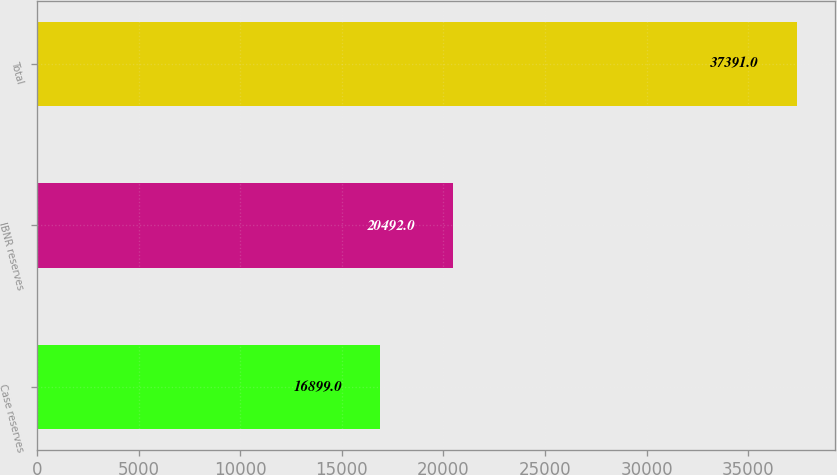<chart> <loc_0><loc_0><loc_500><loc_500><bar_chart><fcel>Case reserves<fcel>IBNR reserves<fcel>Total<nl><fcel>16899<fcel>20492<fcel>37391<nl></chart> 